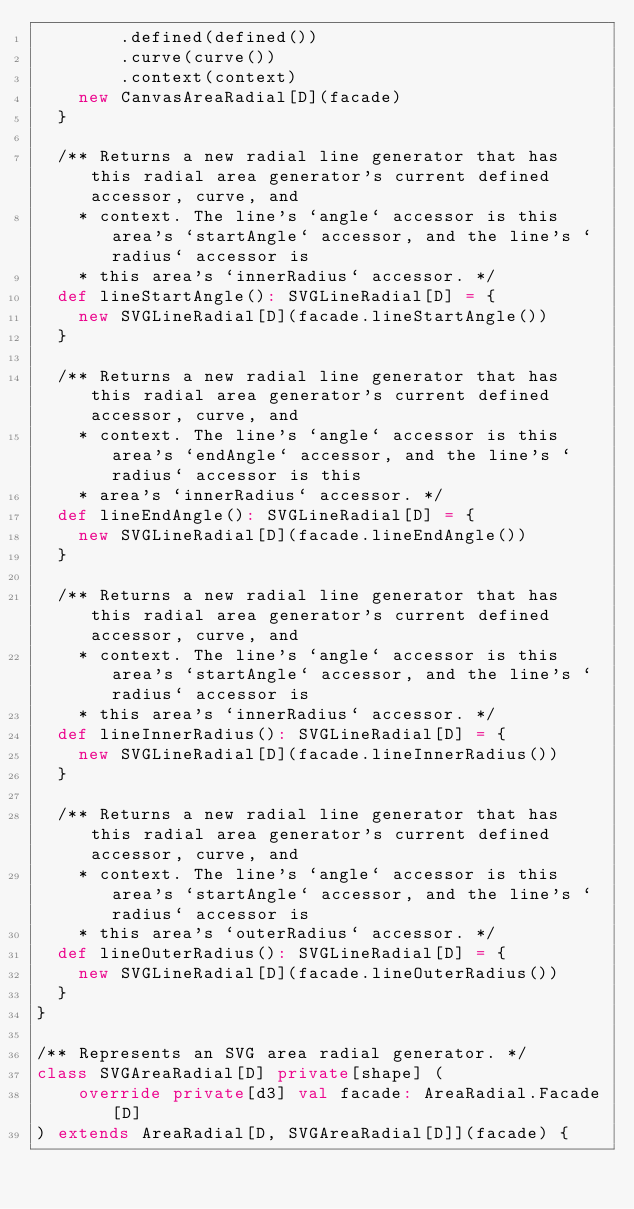<code> <loc_0><loc_0><loc_500><loc_500><_Scala_>        .defined(defined())
        .curve(curve())
        .context(context)
    new CanvasAreaRadial[D](facade)
  }

  /** Returns a new radial line generator that has this radial area generator's current defined accessor, curve, and
    * context. The line's `angle` accessor is this area's `startAngle` accessor, and the line's `radius` accessor is
    * this area's `innerRadius` accessor. */
  def lineStartAngle(): SVGLineRadial[D] = {
    new SVGLineRadial[D](facade.lineStartAngle())
  }

  /** Returns a new radial line generator that has this radial area generator's current defined accessor, curve, and
    * context. The line's `angle` accessor is this area's `endAngle` accessor, and the line's `radius` accessor is this
    * area's `innerRadius` accessor. */
  def lineEndAngle(): SVGLineRadial[D] = {
    new SVGLineRadial[D](facade.lineEndAngle())
  }

  /** Returns a new radial line generator that has this radial area generator's current defined accessor, curve, and
    * context. The line's `angle` accessor is this area's `startAngle` accessor, and the line's `radius` accessor is
    * this area's `innerRadius` accessor. */
  def lineInnerRadius(): SVGLineRadial[D] = {
    new SVGLineRadial[D](facade.lineInnerRadius())
  }

  /** Returns a new radial line generator that has this radial area generator's current defined accessor, curve, and
    * context. The line's `angle` accessor is this area's `startAngle` accessor, and the line's `radius` accessor is
    * this area's `outerRadius` accessor. */
  def lineOuterRadius(): SVGLineRadial[D] = {
    new SVGLineRadial[D](facade.lineOuterRadius())
  }
}

/** Represents an SVG area radial generator. */
class SVGAreaRadial[D] private[shape] (
    override private[d3] val facade: AreaRadial.Facade[D]
) extends AreaRadial[D, SVGAreaRadial[D]](facade) {</code> 